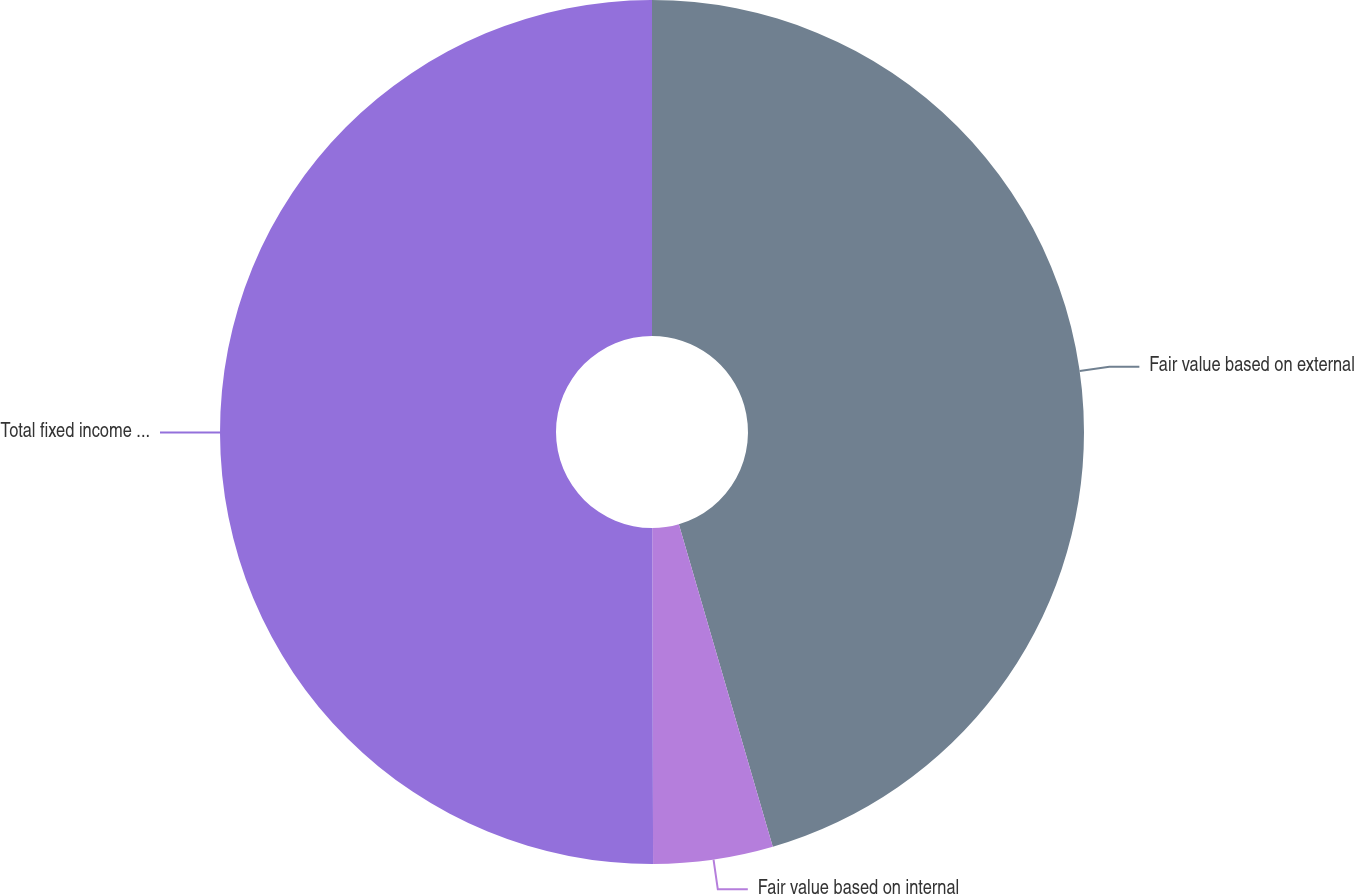Convert chart to OTSL. <chart><loc_0><loc_0><loc_500><loc_500><pie_chart><fcel>Fair value based on external<fcel>Fair value based on internal<fcel>Total fixed income and equity<nl><fcel>45.49%<fcel>4.47%<fcel>50.04%<nl></chart> 